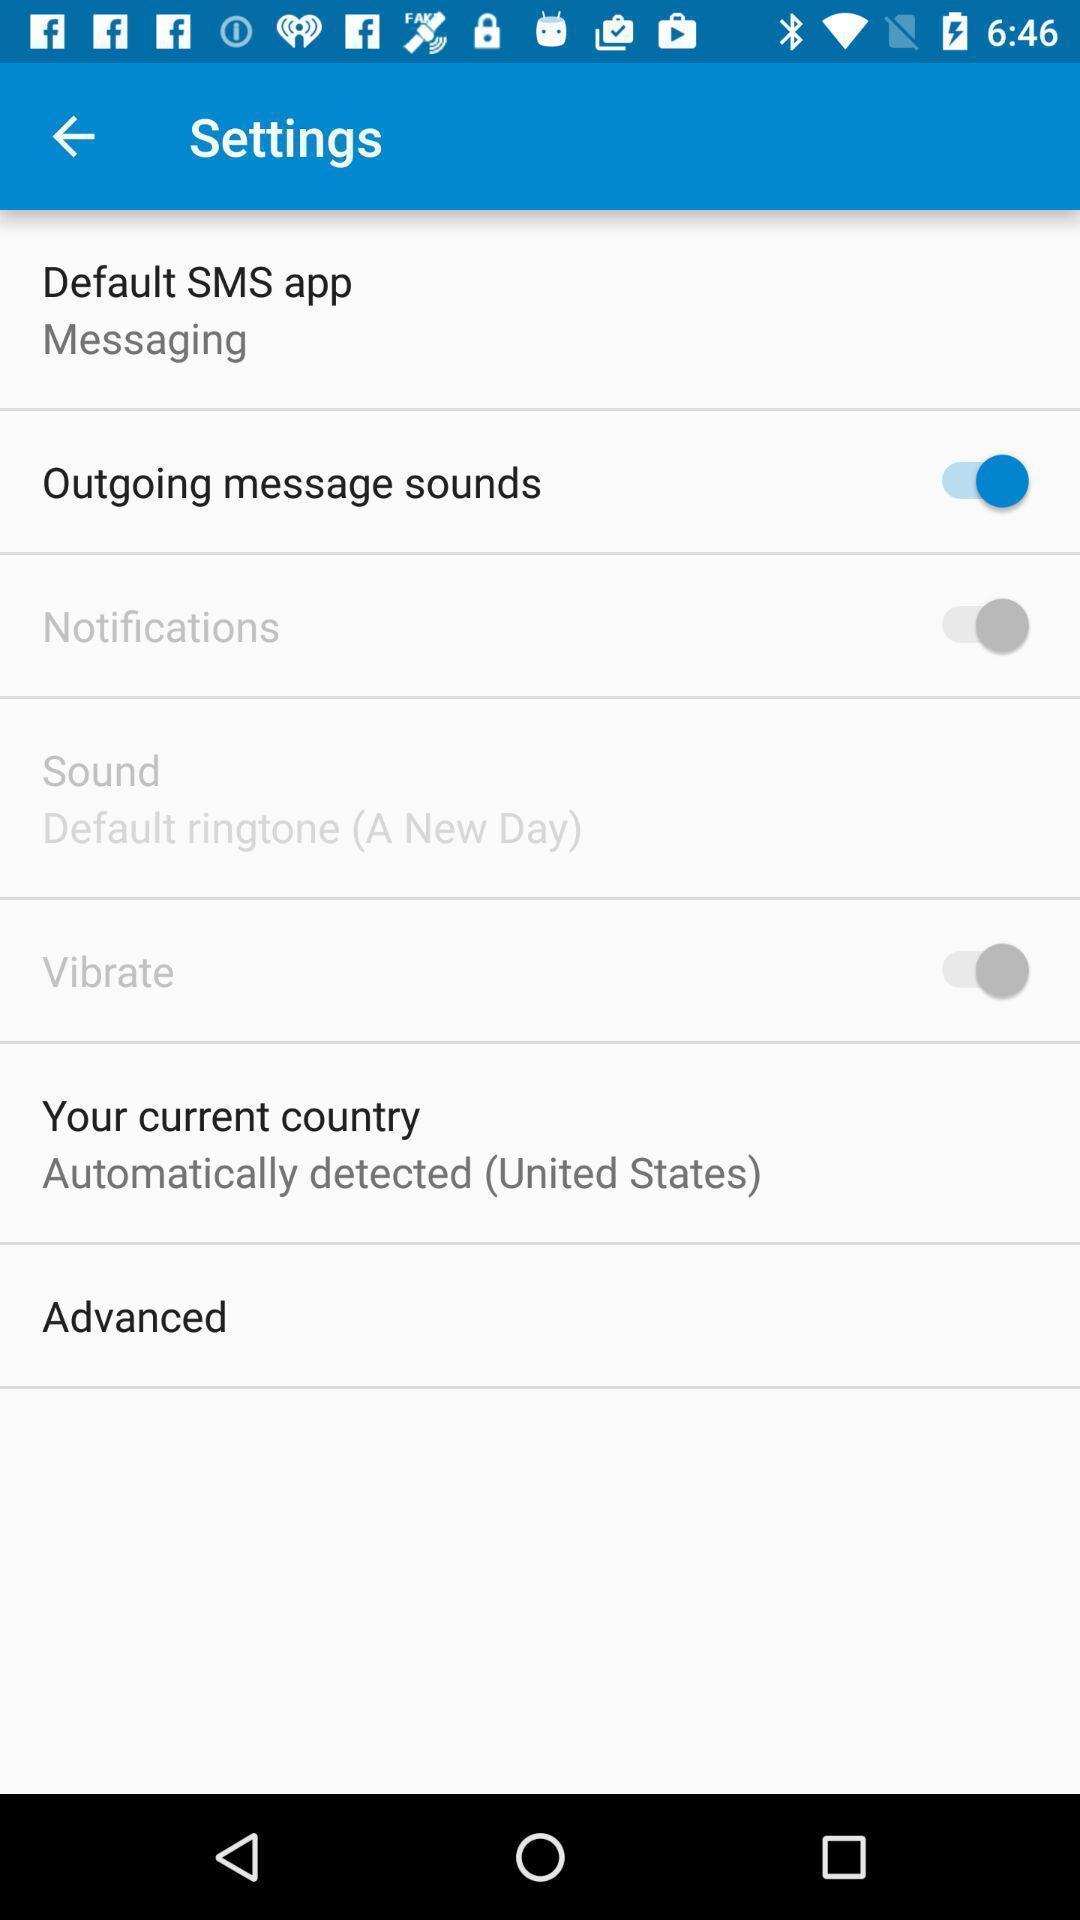Describe the visual elements of this screenshot. Screen displaying multiple options in settings page. 